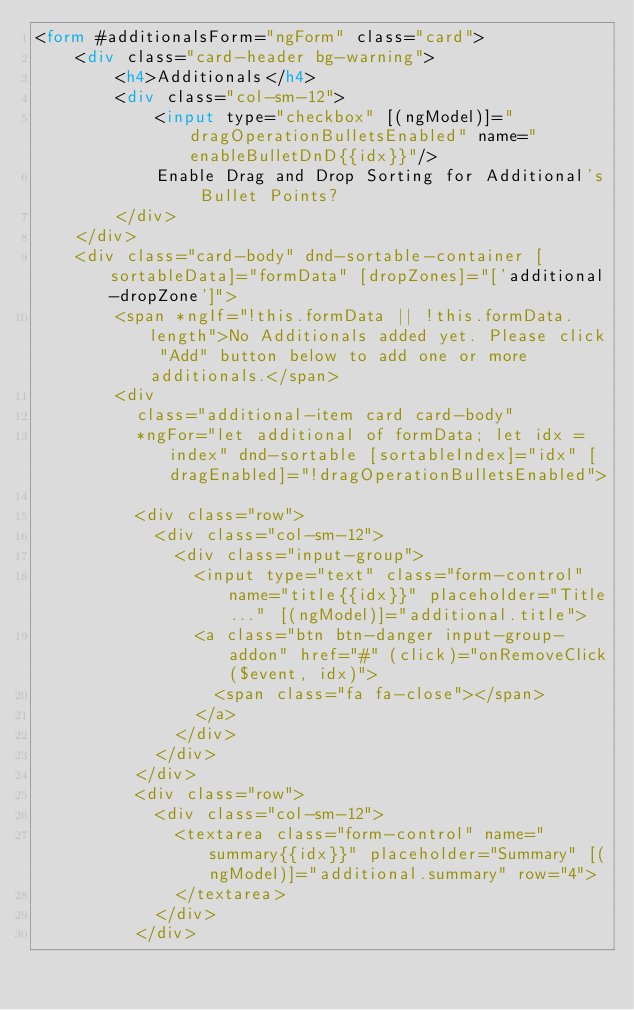<code> <loc_0><loc_0><loc_500><loc_500><_HTML_><form #additionalsForm="ngForm" class="card">
    <div class="card-header bg-warning">
        <h4>Additionals</h4>
        <div class="col-sm-12">
            <input type="checkbox" [(ngModel)]="dragOperationBulletsEnabled" name="enableBulletDnD{{idx}}"/>
            Enable Drag and Drop Sorting for Additional's Bullet Points?
        </div> 
    </div>
    <div class="card-body" dnd-sortable-container [sortableData]="formData" [dropZones]="['additional-dropZone']">      
        <span *ngIf="!this.formData || !this.formData.length">No Additionals added yet. Please click "Add" button below to add one or more additionals.</span>
        <div 
          class="additional-item card card-body"
          *ngFor="let additional of formData; let idx = index" dnd-sortable [sortableIndex]="idx" [dragEnabled]="!dragOperationBulletsEnabled">
            
          <div class="row">                
            <div class="col-sm-12">
              <div class="input-group">
                <input type="text" class="form-control" name="title{{idx}}" placeholder="Title..." [(ngModel)]="additional.title">
                <a class="btn btn-danger input-group-addon" href="#" (click)="onRemoveClick($event, idx)"> 
                  <span class="fa fa-close"></span>
                </a>
              </div>  
            </div>
          </div>
          <div class="row">            
            <div class="col-sm-12">
              <textarea class="form-control" name="summary{{idx}}" placeholder="Summary" [(ngModel)]="additional.summary" row="4">
              </textarea>
            </div>
          </div></code> 